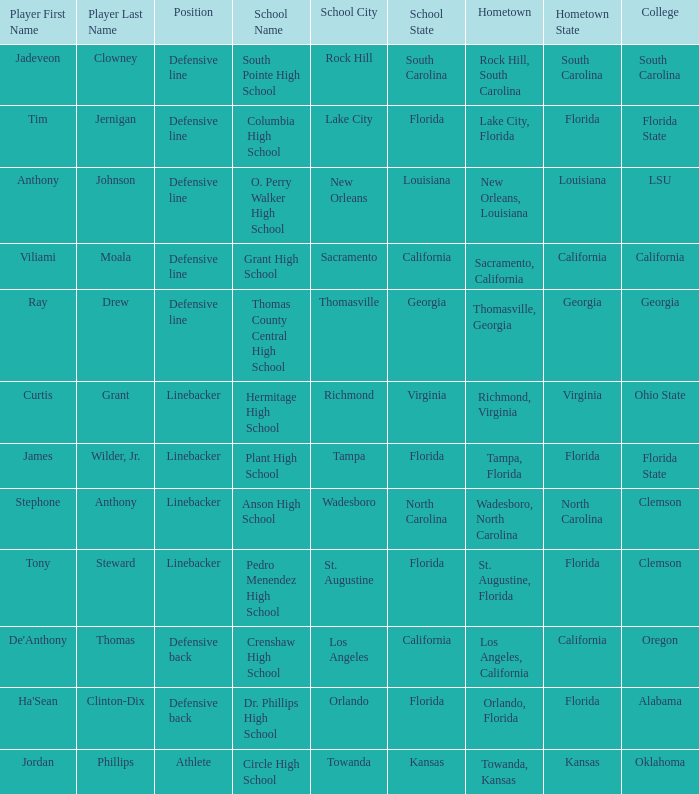What position is for Dr. Phillips high school? Defensive back. 